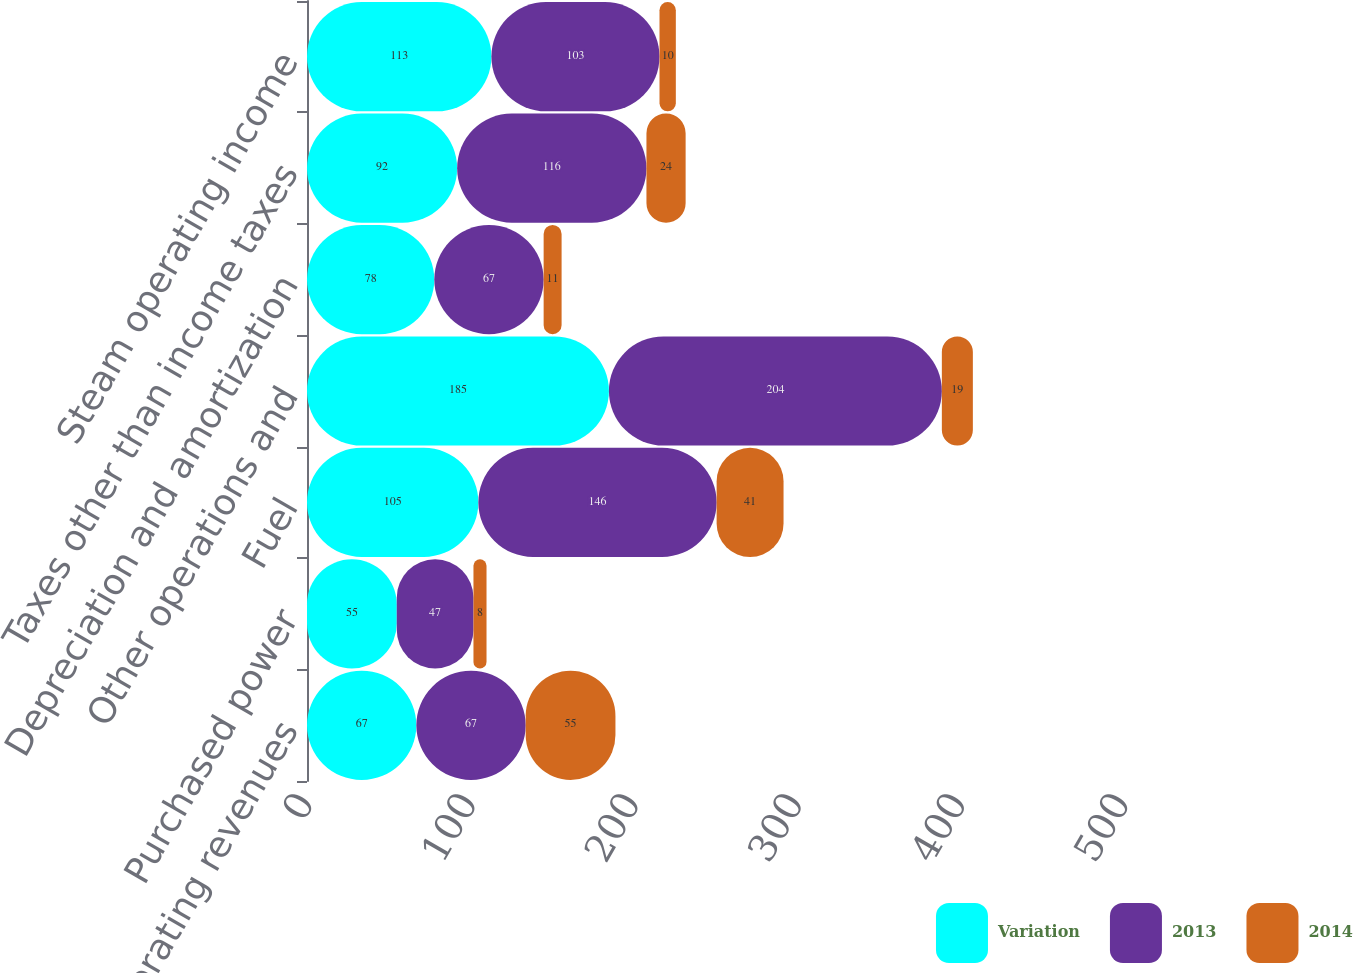<chart> <loc_0><loc_0><loc_500><loc_500><stacked_bar_chart><ecel><fcel>Operating revenues<fcel>Purchased power<fcel>Fuel<fcel>Other operations and<fcel>Depreciation and amortization<fcel>Taxes other than income taxes<fcel>Steam operating income<nl><fcel>Variation<fcel>67<fcel>55<fcel>105<fcel>185<fcel>78<fcel>92<fcel>113<nl><fcel>2013<fcel>67<fcel>47<fcel>146<fcel>204<fcel>67<fcel>116<fcel>103<nl><fcel>2014<fcel>55<fcel>8<fcel>41<fcel>19<fcel>11<fcel>24<fcel>10<nl></chart> 